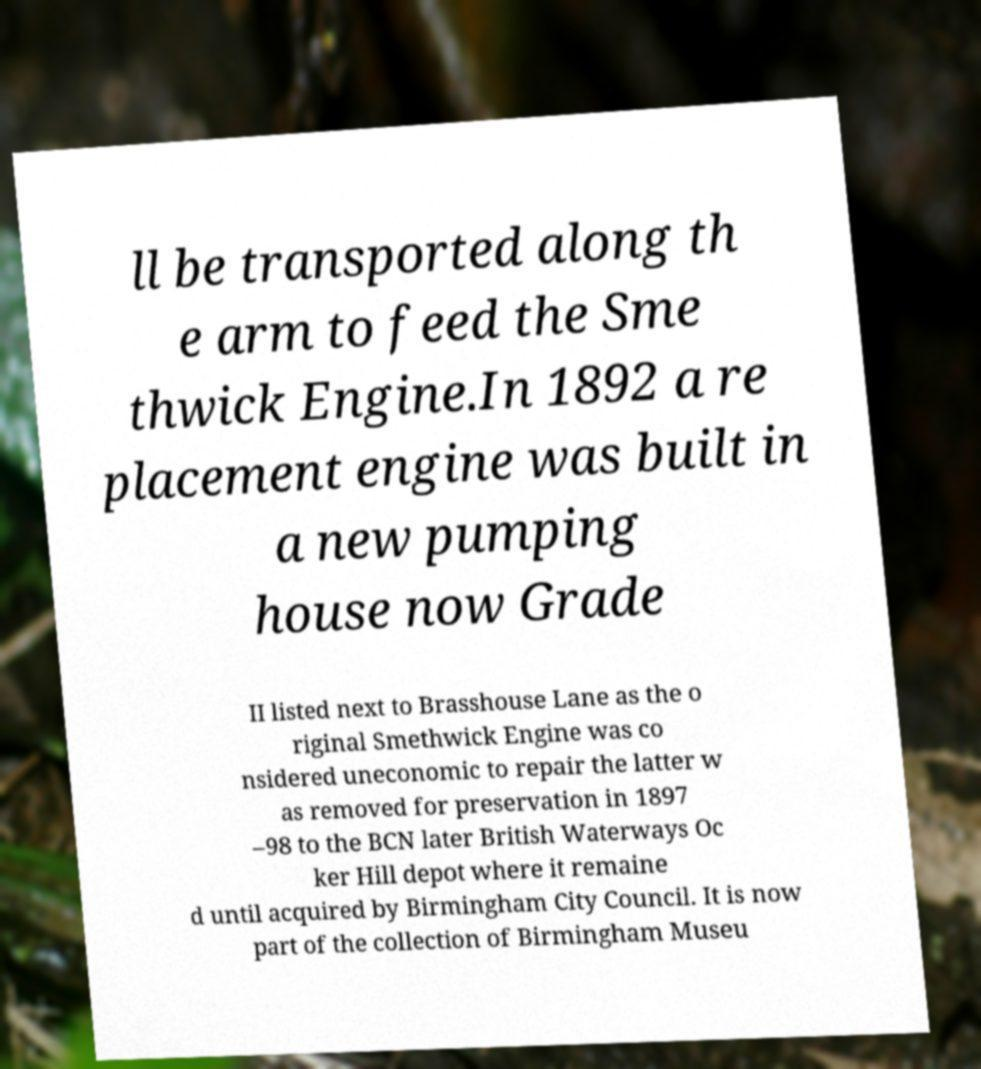I need the written content from this picture converted into text. Can you do that? ll be transported along th e arm to feed the Sme thwick Engine.In 1892 a re placement engine was built in a new pumping house now Grade II listed next to Brasshouse Lane as the o riginal Smethwick Engine was co nsidered uneconomic to repair the latter w as removed for preservation in 1897 –98 to the BCN later British Waterways Oc ker Hill depot where it remaine d until acquired by Birmingham City Council. It is now part of the collection of Birmingham Museu 